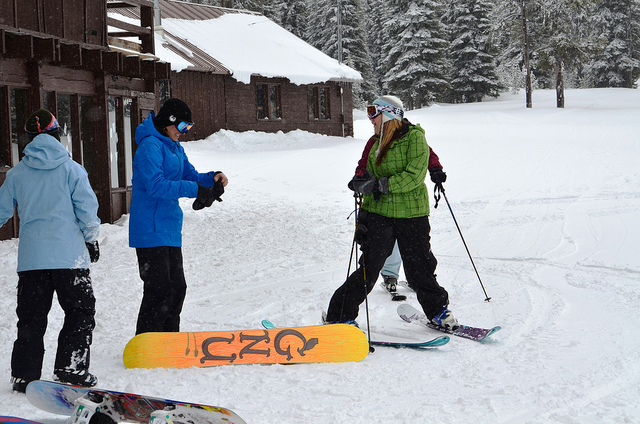Please identify all text content in this image. GNU 